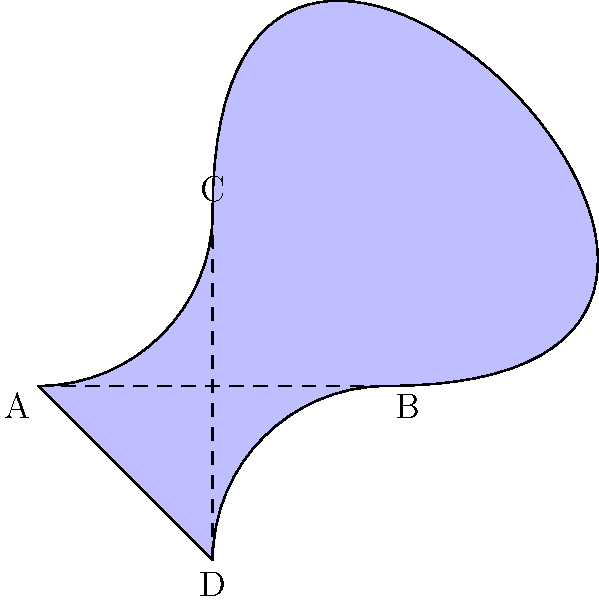As a theater producer, you're working on a unique stage design inspired by a Möbius strip. The design is represented by the shape ABCD in the diagram. If an actor starts at point A and walks along the surface, in how many rotations will they return to point A facing the same direction they started? To solve this problem, we need to understand the properties of a Möbius strip and how they apply to our stage design:

1. A Möbius strip is a non-orientable surface with only one side and one edge.

2. In our diagram, the path ABCD represents a cross-section of the Möbius strip-inspired stage.

3. To return to the starting point facing the same direction, an actor needs to traverse the entire surface twice:

   a. First rotation: The actor starts at A, moves to B, then to C, and back to A. However, they will now be facing the opposite direction.
   
   b. Second rotation: The actor continues from A to B, then to C, and finally back to A, now facing the original direction.

4. Each complete circuit of the stage (ABCDA) represents one rotation.

5. Therefore, it takes two complete rotations for the actor to return to point A facing the same direction they started.

This unique property of the Möbius strip creates interesting possibilities for stage performances, allowing actors to seamlessly transition between different "sides" of the stage without breaking the illusion of continuous movement.
Answer: 2 rotations 